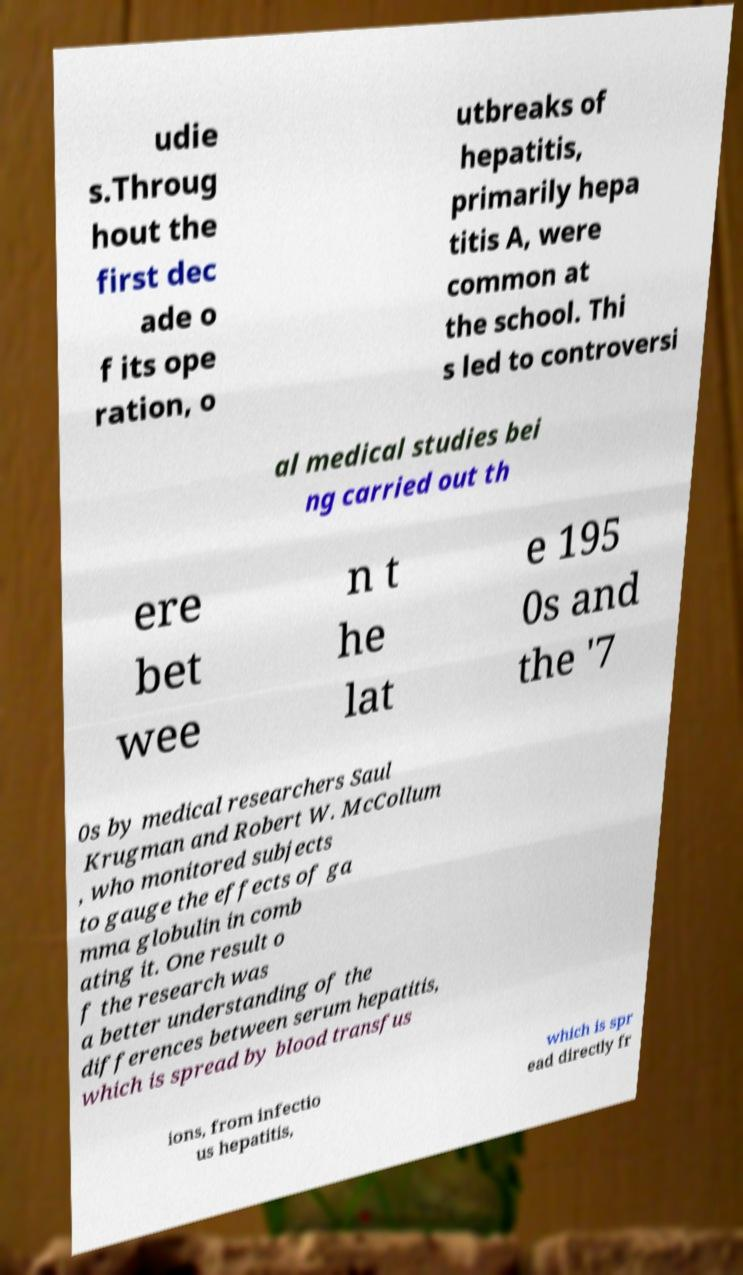Please read and relay the text visible in this image. What does it say? udie s.Throug hout the first dec ade o f its ope ration, o utbreaks of hepatitis, primarily hepa titis A, were common at the school. Thi s led to controversi al medical studies bei ng carried out th ere bet wee n t he lat e 195 0s and the '7 0s by medical researchers Saul Krugman and Robert W. McCollum , who monitored subjects to gauge the effects of ga mma globulin in comb ating it. One result o f the research was a better understanding of the differences between serum hepatitis, which is spread by blood transfus ions, from infectio us hepatitis, which is spr ead directly fr 